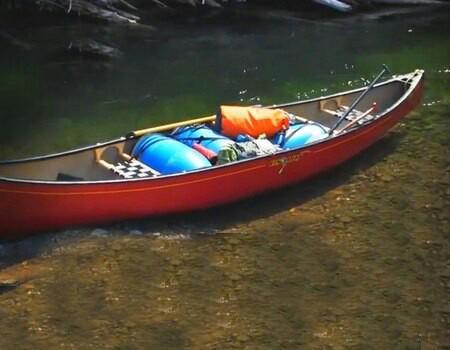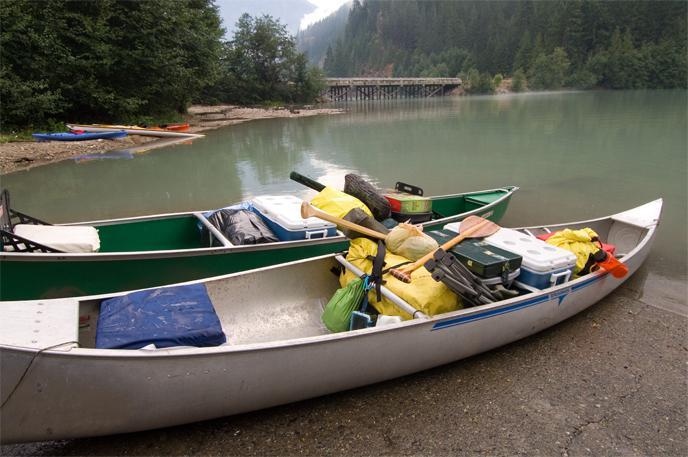The first image is the image on the left, the second image is the image on the right. Considering the images on both sides, is "All boats are pictured in an area with water and full of gear, but no boats have a person inside." valid? Answer yes or no. Yes. The first image is the image on the left, the second image is the image on the right. For the images displayed, is the sentence "The right image includes one red canoe." factually correct? Answer yes or no. No. 